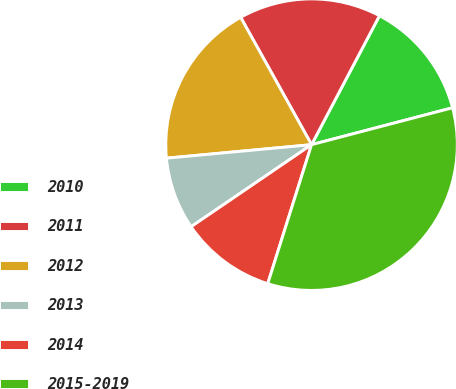Convert chart to OTSL. <chart><loc_0><loc_0><loc_500><loc_500><pie_chart><fcel>2010<fcel>2011<fcel>2012<fcel>2013<fcel>2014<fcel>2015-2019<nl><fcel>13.21%<fcel>15.8%<fcel>18.39%<fcel>8.04%<fcel>10.62%<fcel>33.93%<nl></chart> 